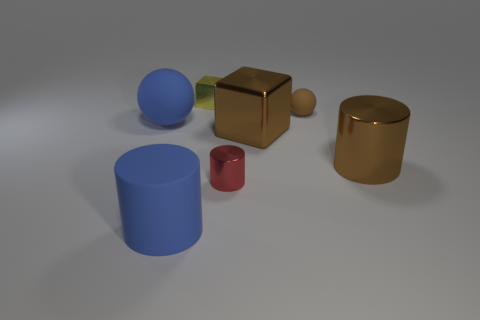The rubber thing that is the same size as the yellow shiny thing is what color?
Your response must be concise. Brown. Are there any small brown rubber objects that are on the left side of the sphere that is right of the small shiny thing behind the small brown matte thing?
Give a very brief answer. No. What material is the block behind the blue matte ball?
Provide a succinct answer. Metal. Do the tiny red shiny object and the large blue matte object behind the small red metal object have the same shape?
Your answer should be compact. No. Is the number of rubber things that are behind the brown matte sphere the same as the number of blue rubber cylinders that are behind the large blue cylinder?
Keep it short and to the point. Yes. How many other objects are the same material as the tiny red cylinder?
Your response must be concise. 3. What number of shiny things are red objects or brown spheres?
Offer a very short reply. 1. There is a brown object on the right side of the small matte sphere; is its shape the same as the yellow object?
Your answer should be very brief. No. Are there more shiny cubes in front of the tiny metal block than blue rubber things?
Ensure brevity in your answer.  No. How many large things are left of the tiny yellow shiny thing and right of the blue sphere?
Your answer should be very brief. 1. 